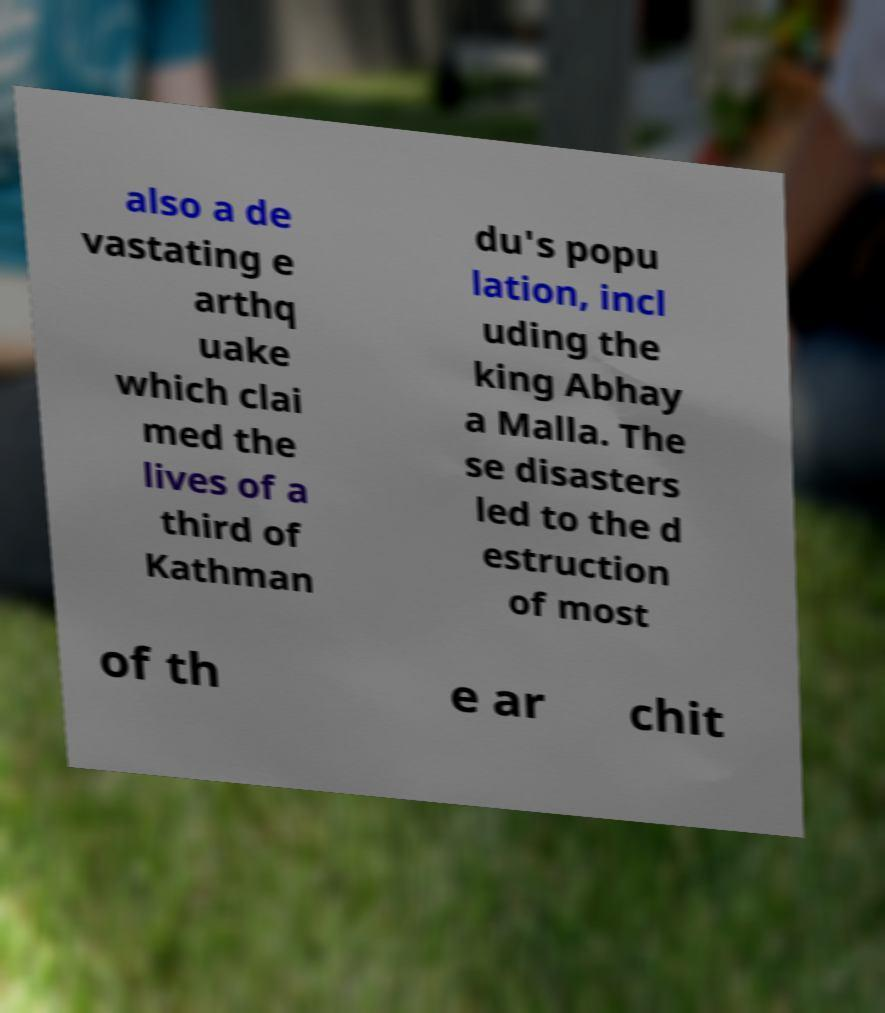Please read and relay the text visible in this image. What does it say? also a de vastating e arthq uake which clai med the lives of a third of Kathman du's popu lation, incl uding the king Abhay a Malla. The se disasters led to the d estruction of most of th e ar chit 